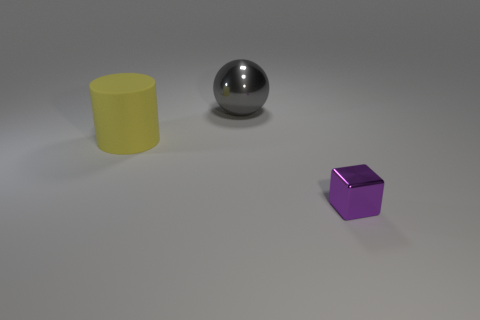Add 1 large gray spheres. How many objects exist? 4 Subtract 1 cubes. How many cubes are left? 0 Subtract all cylinders. How many objects are left? 2 Subtract all purple cylinders. Subtract all gray spheres. How many cylinders are left? 1 Subtract all cubes. Subtract all yellow things. How many objects are left? 1 Add 2 cylinders. How many cylinders are left? 3 Add 2 small purple objects. How many small purple objects exist? 3 Subtract 0 purple cylinders. How many objects are left? 3 